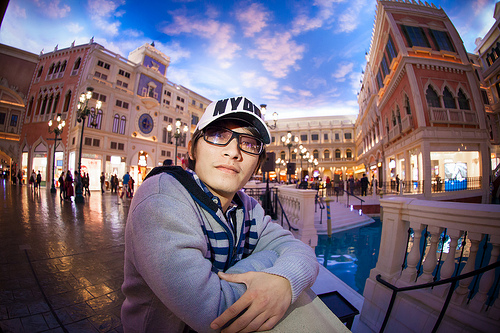<image>
Is there a glasses under the cap? Yes. The glasses is positioned underneath the cap, with the cap above it in the vertical space. 